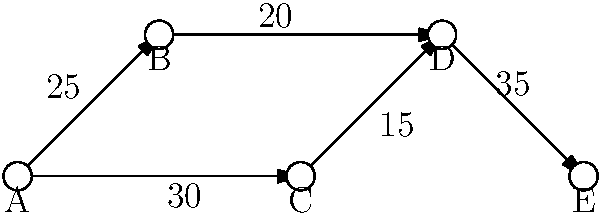The network diagram above represents hospital referral patterns within a state, where nodes represent hospitals and directed edges represent patient referrals with their corresponding volumes. As the state health department representative, you need to identify potential bottlenecks in the referral system. Which hospital is most likely to experience overcrowding, and what is the total number of patients it receives from direct referrals? To identify the hospital most likely to experience overcrowding and calculate the total number of patients it receives from direct referrals, we need to follow these steps:

1. Analyze the network structure:
   - Hospital A refers patients to B and C
   - Hospital B refers patients to D
   - Hospital C refers patients to D
   - Hospital D refers patients to E

2. Calculate incoming referrals for each hospital:
   - Hospital A: 0 (no incoming referrals)
   - Hospital B: 25 (from A)
   - Hospital C: 30 (from A)
   - Hospital D: 20 (from B) + 15 (from C) = 35
   - Hospital E: 35 (from D)

3. Identify the hospital with the highest number of incoming referrals:
   Hospital D receives the most referrals (35), making it the most likely to experience overcrowding.

4. Calculate the total number of patients Hospital D receives from direct referrals:
   20 (from B) + 15 (from C) = 35 patients

Therefore, Hospital D is most likely to experience overcrowding, receiving a total of 35 patients from direct referrals.
Answer: Hospital D, 35 patients 